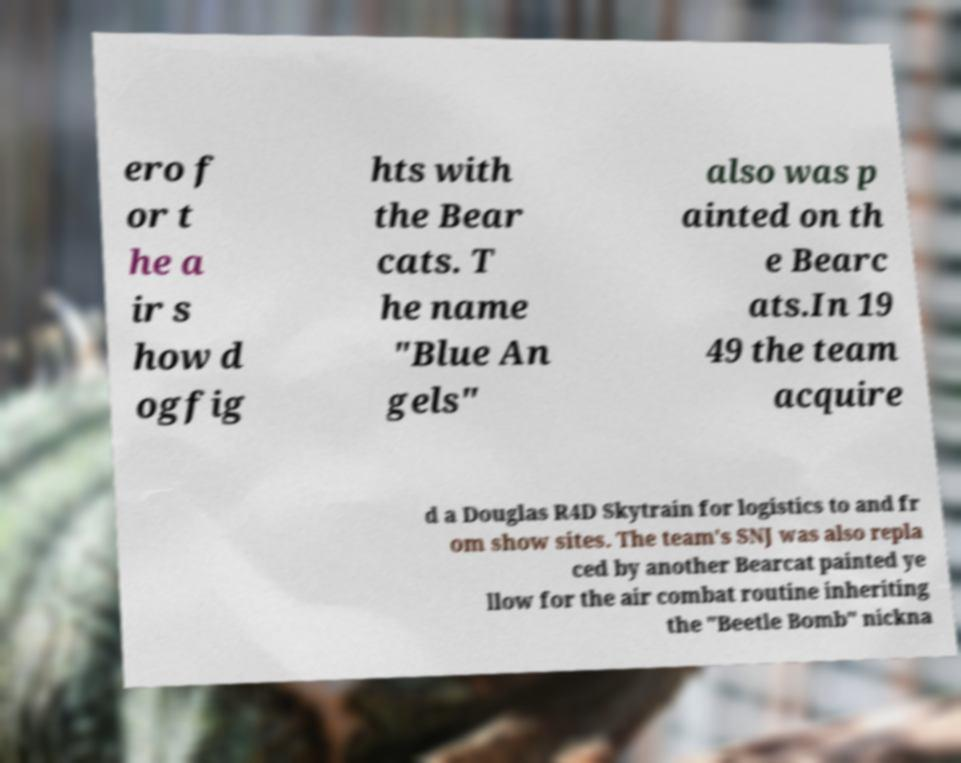Can you read and provide the text displayed in the image?This photo seems to have some interesting text. Can you extract and type it out for me? ero f or t he a ir s how d ogfig hts with the Bear cats. T he name "Blue An gels" also was p ainted on th e Bearc ats.In 19 49 the team acquire d a Douglas R4D Skytrain for logistics to and fr om show sites. The team's SNJ was also repla ced by another Bearcat painted ye llow for the air combat routine inheriting the "Beetle Bomb" nickna 